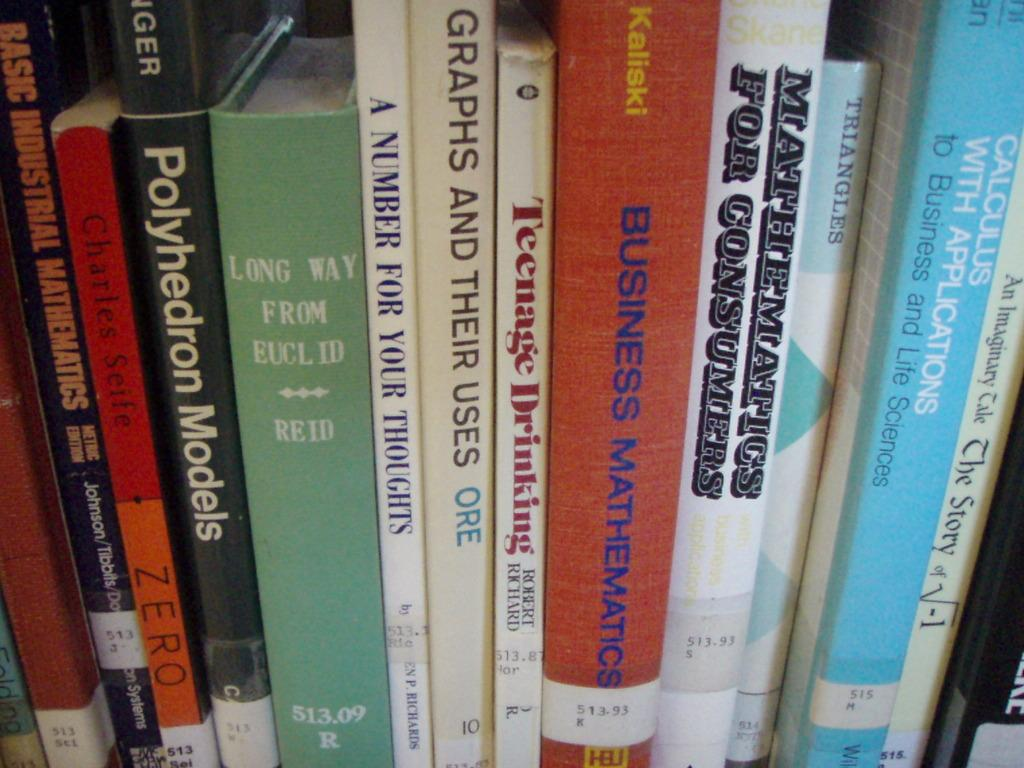<image>
Share a concise interpretation of the image provided. A collection of books on a shelf has titles such as Long Way From Euclid, GRAPHS AND THEIR USES, and MATHEMATICS FOR CONSUMERS. 